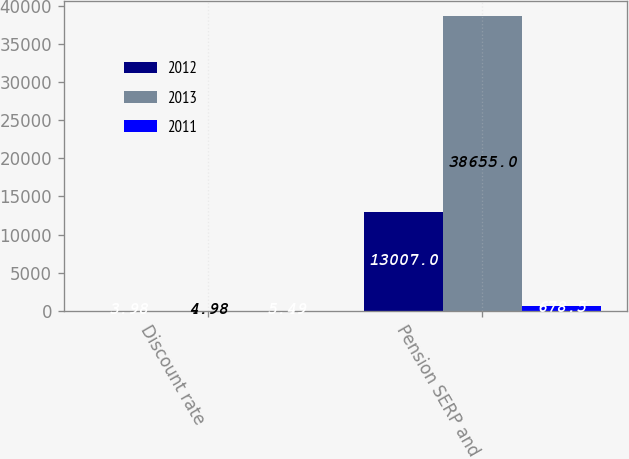Convert chart to OTSL. <chart><loc_0><loc_0><loc_500><loc_500><stacked_bar_chart><ecel><fcel>Discount rate<fcel>Pension SERP and<nl><fcel>2012<fcel>3.98<fcel>13007<nl><fcel>2013<fcel>4.98<fcel>38655<nl><fcel>2011<fcel>5.49<fcel>678.5<nl></chart> 